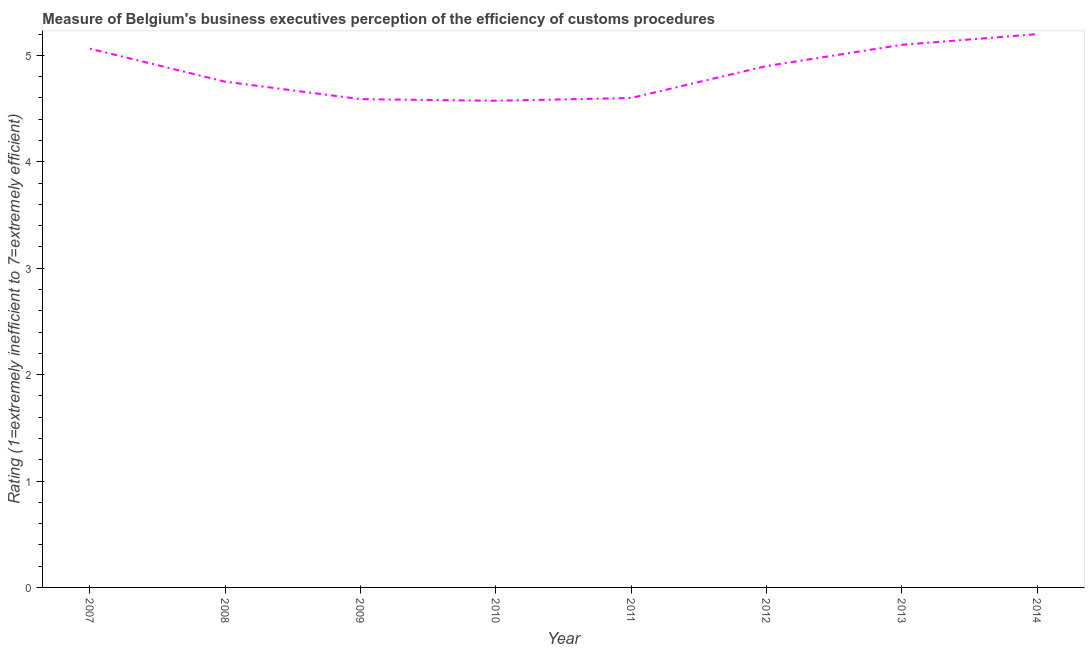What is the rating measuring burden of customs procedure in 2009?
Offer a terse response. 4.59. Across all years, what is the maximum rating measuring burden of customs procedure?
Ensure brevity in your answer.  5.2. Across all years, what is the minimum rating measuring burden of customs procedure?
Provide a succinct answer. 4.57. What is the sum of the rating measuring burden of customs procedure?
Ensure brevity in your answer.  38.78. What is the difference between the rating measuring burden of customs procedure in 2008 and 2009?
Ensure brevity in your answer.  0.16. What is the average rating measuring burden of customs procedure per year?
Your response must be concise. 4.85. What is the median rating measuring burden of customs procedure?
Your answer should be compact. 4.83. Do a majority of the years between 2013 and 2012 (inclusive) have rating measuring burden of customs procedure greater than 0.2 ?
Make the answer very short. No. What is the ratio of the rating measuring burden of customs procedure in 2008 to that in 2013?
Ensure brevity in your answer.  0.93. What is the difference between the highest and the second highest rating measuring burden of customs procedure?
Give a very brief answer. 0.1. What is the difference between the highest and the lowest rating measuring burden of customs procedure?
Offer a terse response. 0.63. In how many years, is the rating measuring burden of customs procedure greater than the average rating measuring burden of customs procedure taken over all years?
Offer a very short reply. 4. What is the difference between two consecutive major ticks on the Y-axis?
Your answer should be compact. 1. Does the graph contain any zero values?
Give a very brief answer. No. What is the title of the graph?
Your response must be concise. Measure of Belgium's business executives perception of the efficiency of customs procedures. What is the label or title of the X-axis?
Give a very brief answer. Year. What is the label or title of the Y-axis?
Offer a terse response. Rating (1=extremely inefficient to 7=extremely efficient). What is the Rating (1=extremely inefficient to 7=extremely efficient) in 2007?
Ensure brevity in your answer.  5.06. What is the Rating (1=extremely inefficient to 7=extremely efficient) in 2008?
Your response must be concise. 4.75. What is the Rating (1=extremely inefficient to 7=extremely efficient) in 2009?
Give a very brief answer. 4.59. What is the Rating (1=extremely inefficient to 7=extremely efficient) in 2010?
Your answer should be compact. 4.57. What is the difference between the Rating (1=extremely inefficient to 7=extremely efficient) in 2007 and 2008?
Give a very brief answer. 0.31. What is the difference between the Rating (1=extremely inefficient to 7=extremely efficient) in 2007 and 2009?
Ensure brevity in your answer.  0.47. What is the difference between the Rating (1=extremely inefficient to 7=extremely efficient) in 2007 and 2010?
Your response must be concise. 0.49. What is the difference between the Rating (1=extremely inefficient to 7=extremely efficient) in 2007 and 2011?
Provide a short and direct response. 0.46. What is the difference between the Rating (1=extremely inefficient to 7=extremely efficient) in 2007 and 2012?
Your answer should be compact. 0.16. What is the difference between the Rating (1=extremely inefficient to 7=extremely efficient) in 2007 and 2013?
Provide a short and direct response. -0.04. What is the difference between the Rating (1=extremely inefficient to 7=extremely efficient) in 2007 and 2014?
Give a very brief answer. -0.14. What is the difference between the Rating (1=extremely inefficient to 7=extremely efficient) in 2008 and 2009?
Provide a short and direct response. 0.16. What is the difference between the Rating (1=extremely inefficient to 7=extremely efficient) in 2008 and 2010?
Your answer should be compact. 0.18. What is the difference between the Rating (1=extremely inefficient to 7=extremely efficient) in 2008 and 2011?
Your answer should be compact. 0.15. What is the difference between the Rating (1=extremely inefficient to 7=extremely efficient) in 2008 and 2012?
Make the answer very short. -0.15. What is the difference between the Rating (1=extremely inefficient to 7=extremely efficient) in 2008 and 2013?
Keep it short and to the point. -0.35. What is the difference between the Rating (1=extremely inefficient to 7=extremely efficient) in 2008 and 2014?
Offer a terse response. -0.45. What is the difference between the Rating (1=extremely inefficient to 7=extremely efficient) in 2009 and 2010?
Offer a terse response. 0.02. What is the difference between the Rating (1=extremely inefficient to 7=extremely efficient) in 2009 and 2011?
Keep it short and to the point. -0.01. What is the difference between the Rating (1=extremely inefficient to 7=extremely efficient) in 2009 and 2012?
Keep it short and to the point. -0.31. What is the difference between the Rating (1=extremely inefficient to 7=extremely efficient) in 2009 and 2013?
Your answer should be very brief. -0.51. What is the difference between the Rating (1=extremely inefficient to 7=extremely efficient) in 2009 and 2014?
Offer a very short reply. -0.61. What is the difference between the Rating (1=extremely inefficient to 7=extremely efficient) in 2010 and 2011?
Your response must be concise. -0.03. What is the difference between the Rating (1=extremely inefficient to 7=extremely efficient) in 2010 and 2012?
Provide a short and direct response. -0.33. What is the difference between the Rating (1=extremely inefficient to 7=extremely efficient) in 2010 and 2013?
Give a very brief answer. -0.53. What is the difference between the Rating (1=extremely inefficient to 7=extremely efficient) in 2010 and 2014?
Provide a succinct answer. -0.63. What is the difference between the Rating (1=extremely inefficient to 7=extremely efficient) in 2011 and 2012?
Your answer should be compact. -0.3. What is the difference between the Rating (1=extremely inefficient to 7=extremely efficient) in 2011 and 2013?
Offer a terse response. -0.5. What is the difference between the Rating (1=extremely inefficient to 7=extremely efficient) in 2012 and 2013?
Your answer should be compact. -0.2. What is the difference between the Rating (1=extremely inefficient to 7=extremely efficient) in 2012 and 2014?
Your answer should be compact. -0.3. What is the ratio of the Rating (1=extremely inefficient to 7=extremely efficient) in 2007 to that in 2008?
Your answer should be very brief. 1.06. What is the ratio of the Rating (1=extremely inefficient to 7=extremely efficient) in 2007 to that in 2009?
Offer a terse response. 1.1. What is the ratio of the Rating (1=extremely inefficient to 7=extremely efficient) in 2007 to that in 2010?
Provide a short and direct response. 1.11. What is the ratio of the Rating (1=extremely inefficient to 7=extremely efficient) in 2007 to that in 2011?
Your response must be concise. 1.1. What is the ratio of the Rating (1=extremely inefficient to 7=extremely efficient) in 2007 to that in 2012?
Offer a terse response. 1.03. What is the ratio of the Rating (1=extremely inefficient to 7=extremely efficient) in 2007 to that in 2013?
Ensure brevity in your answer.  0.99. What is the ratio of the Rating (1=extremely inefficient to 7=extremely efficient) in 2008 to that in 2009?
Provide a succinct answer. 1.04. What is the ratio of the Rating (1=extremely inefficient to 7=extremely efficient) in 2008 to that in 2010?
Provide a succinct answer. 1.04. What is the ratio of the Rating (1=extremely inefficient to 7=extremely efficient) in 2008 to that in 2011?
Your response must be concise. 1.03. What is the ratio of the Rating (1=extremely inefficient to 7=extremely efficient) in 2008 to that in 2012?
Keep it short and to the point. 0.97. What is the ratio of the Rating (1=extremely inefficient to 7=extremely efficient) in 2008 to that in 2013?
Ensure brevity in your answer.  0.93. What is the ratio of the Rating (1=extremely inefficient to 7=extremely efficient) in 2008 to that in 2014?
Your answer should be compact. 0.91. What is the ratio of the Rating (1=extremely inefficient to 7=extremely efficient) in 2009 to that in 2010?
Provide a short and direct response. 1. What is the ratio of the Rating (1=extremely inefficient to 7=extremely efficient) in 2009 to that in 2012?
Give a very brief answer. 0.94. What is the ratio of the Rating (1=extremely inefficient to 7=extremely efficient) in 2009 to that in 2014?
Keep it short and to the point. 0.88. What is the ratio of the Rating (1=extremely inefficient to 7=extremely efficient) in 2010 to that in 2011?
Your answer should be very brief. 0.99. What is the ratio of the Rating (1=extremely inefficient to 7=extremely efficient) in 2010 to that in 2012?
Your response must be concise. 0.93. What is the ratio of the Rating (1=extremely inefficient to 7=extremely efficient) in 2010 to that in 2013?
Your answer should be compact. 0.9. What is the ratio of the Rating (1=extremely inefficient to 7=extremely efficient) in 2011 to that in 2012?
Give a very brief answer. 0.94. What is the ratio of the Rating (1=extremely inefficient to 7=extremely efficient) in 2011 to that in 2013?
Ensure brevity in your answer.  0.9. What is the ratio of the Rating (1=extremely inefficient to 7=extremely efficient) in 2011 to that in 2014?
Your answer should be very brief. 0.89. What is the ratio of the Rating (1=extremely inefficient to 7=extremely efficient) in 2012 to that in 2013?
Keep it short and to the point. 0.96. What is the ratio of the Rating (1=extremely inefficient to 7=extremely efficient) in 2012 to that in 2014?
Your response must be concise. 0.94. 